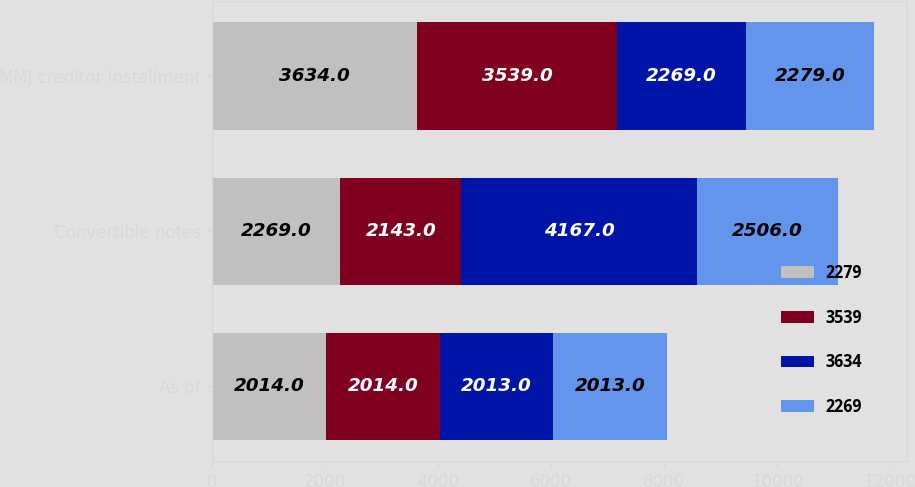Convert chart to OTSL. <chart><loc_0><loc_0><loc_500><loc_500><stacked_bar_chart><ecel><fcel>As of<fcel>Convertible notes<fcel>MMJ creditor installment<nl><fcel>2279<fcel>2014<fcel>2269<fcel>3634<nl><fcel>3539<fcel>2014<fcel>2143<fcel>3539<nl><fcel>3634<fcel>2013<fcel>4167<fcel>2269<nl><fcel>2269<fcel>2013<fcel>2506<fcel>2279<nl></chart> 